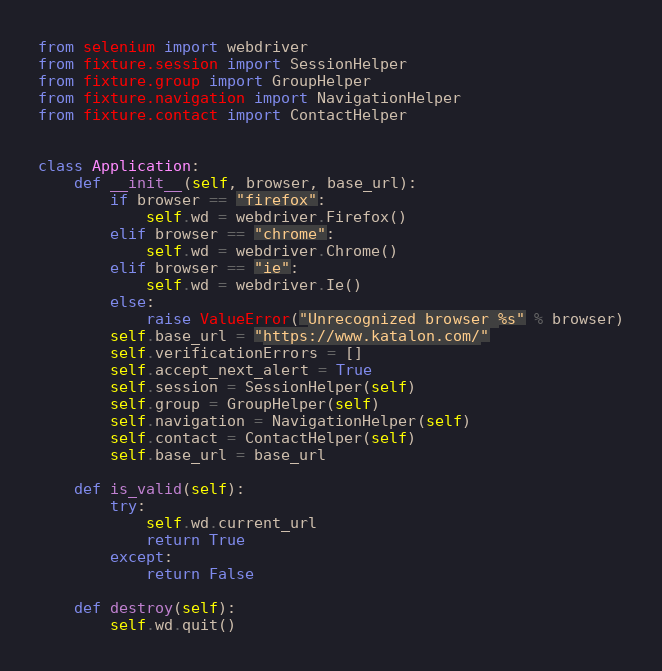<code> <loc_0><loc_0><loc_500><loc_500><_Python_>from selenium import webdriver
from fixture.session import SessionHelper
from fixture.group import GroupHelper
from fixture.navigation import NavigationHelper
from fixture.contact import ContactHelper


class Application:
    def __init__(self, browser, base_url):
        if browser == "firefox":
            self.wd = webdriver.Firefox()
        elif browser == "chrome":
            self.wd = webdriver.Chrome()
        elif browser == "ie":
            self.wd = webdriver.Ie()
        else:
            raise ValueError("Unrecognized browser %s" % browser)
        self.base_url = "https://www.katalon.com/"
        self.verificationErrors = []
        self.accept_next_alert = True
        self.session = SessionHelper(self)
        self.group = GroupHelper(self)
        self.navigation = NavigationHelper(self)
        self.contact = ContactHelper(self)
        self.base_url = base_url

    def is_valid(self):
        try:
            self.wd.current_url
            return True
        except:
            return False

    def destroy(self):
        self.wd.quit()




</code> 